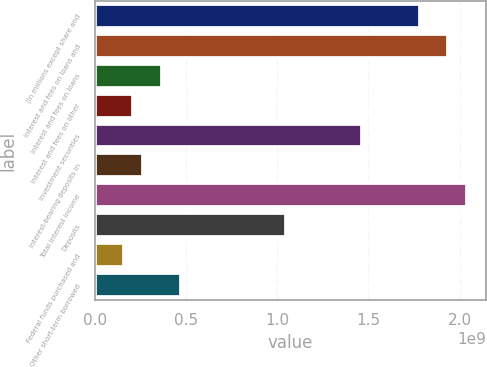Convert chart to OTSL. <chart><loc_0><loc_0><loc_500><loc_500><bar_chart><fcel>(in millions except share and<fcel>Interest and fees on loans and<fcel>Interest and fees on loans<fcel>Interest and fees on other<fcel>Investment securities<fcel>Interest-bearing deposits in<fcel>Total interest income<fcel>Deposits<fcel>Federal funds purchased and<fcel>Other short-term borrowed<nl><fcel>1.78136e+09<fcel>1.93854e+09<fcel>3.66752e+08<fcel>2.09572e+08<fcel>1.46701e+09<fcel>2.61965e+08<fcel>2.04333e+09<fcel>1.04786e+09<fcel>1.57179e+08<fcel>4.71538e+08<nl></chart> 